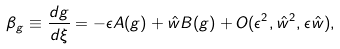<formula> <loc_0><loc_0><loc_500><loc_500>\beta _ { g } \equiv \frac { d g } { d \xi } = - \epsilon A ( g ) + \hat { w } B ( g ) + O ( \epsilon ^ { 2 } , \hat { w } ^ { 2 } , \epsilon \hat { w } ) ,</formula> 